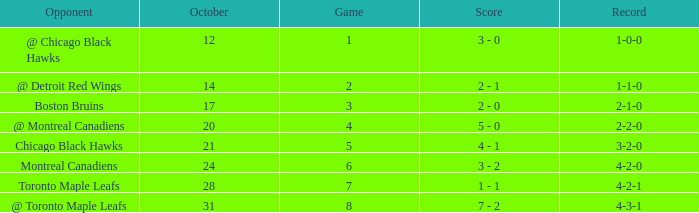What was the score of the game after game 6 on October 28? 1 - 1. 